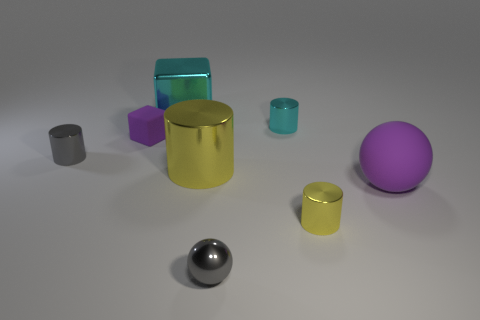Could you guess the material of the purple matte sphere? Based on its appearance, the purple matte sphere likely resembles a rubber-like material due to its non-reflective and slightly textured surface. 